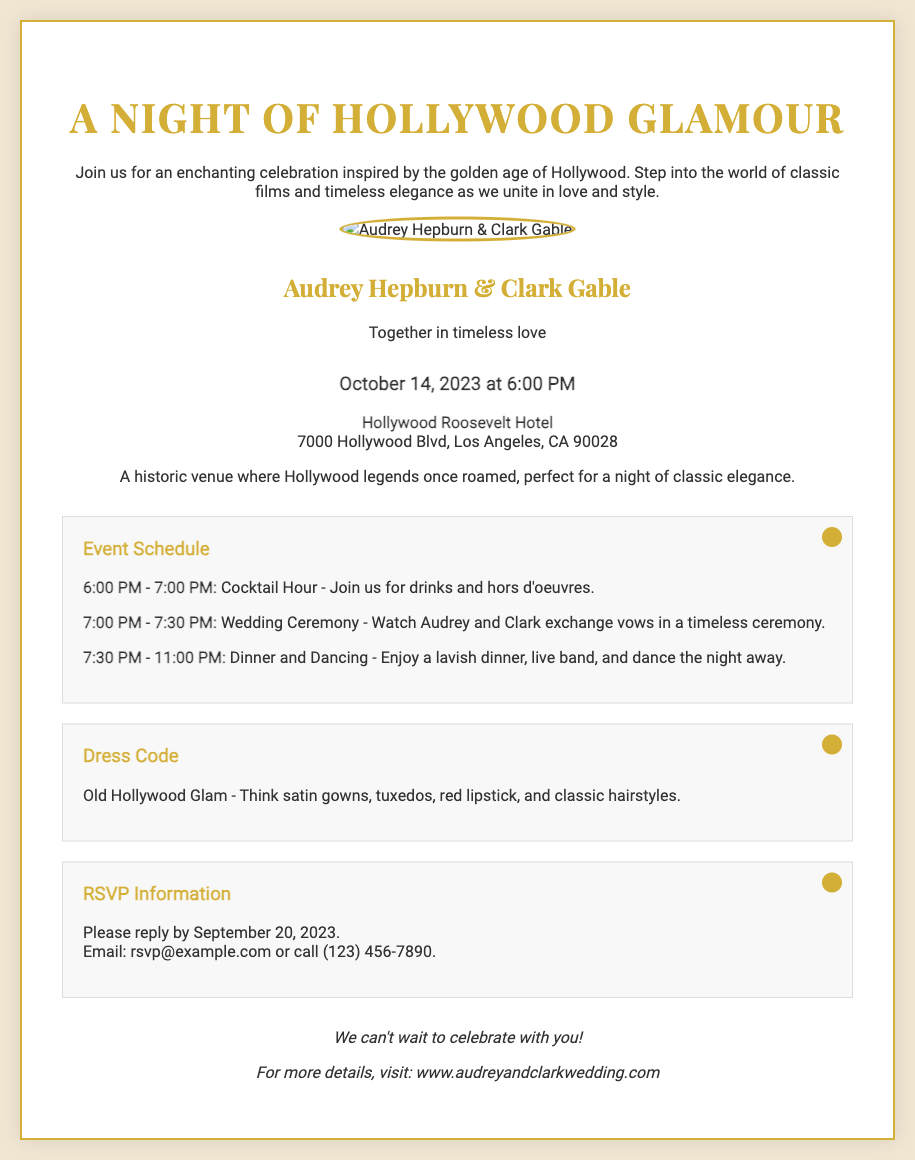What is the main theme of the invitation? The invitation is designed to celebrate an occasion inspired by the golden age of Hollywood.
Answer: Hollywood Glamour Who are the couple getting married? The couple's names featured on the invitation are provided prominently.
Answer: Audrey Hepburn & Clark Gable What date is the wedding taking place? The date of the event is clearly stated in the invitation details.
Answer: October 14, 2023 What venue is hosting the wedding? The location of the wedding is mentioned in the event details section.
Answer: Hollywood Roosevelt Hotel What is the RSVP deadline? The invitation specifies a date by which guests should respond.
Answer: September 20, 2023 What type of dress code is requested? The invitation includes a specific style of attire for guests to wear.
Answer: Old Hollywood Glam How long is the cocktail hour? The schedule includes the duration of the cocktail hour.
Answer: 1 hour What can guests expect during the dinner and dancing segment? The schedule outlines the activities planned during this part of the event.
Answer: Lavish dinner and live band What is the RSVP email address? The invitation provides contact information for responding to the invitation.
Answer: rsvp@example.com 